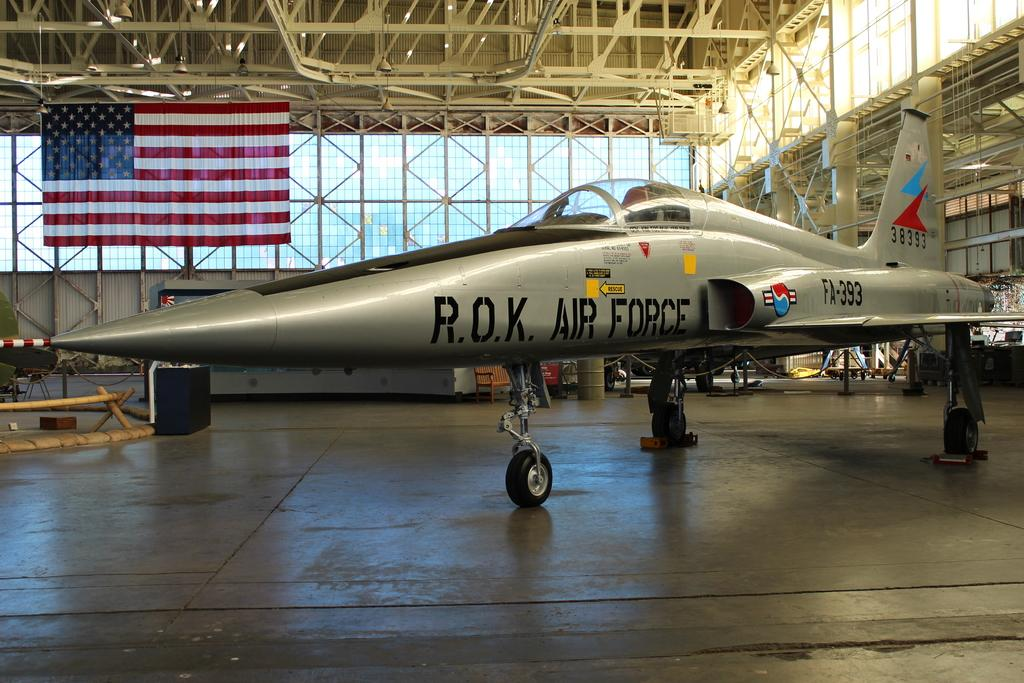<image>
Offer a succinct explanation of the picture presented. A silver fighter R.O.K. Air Force jet is parked in a hanger. 